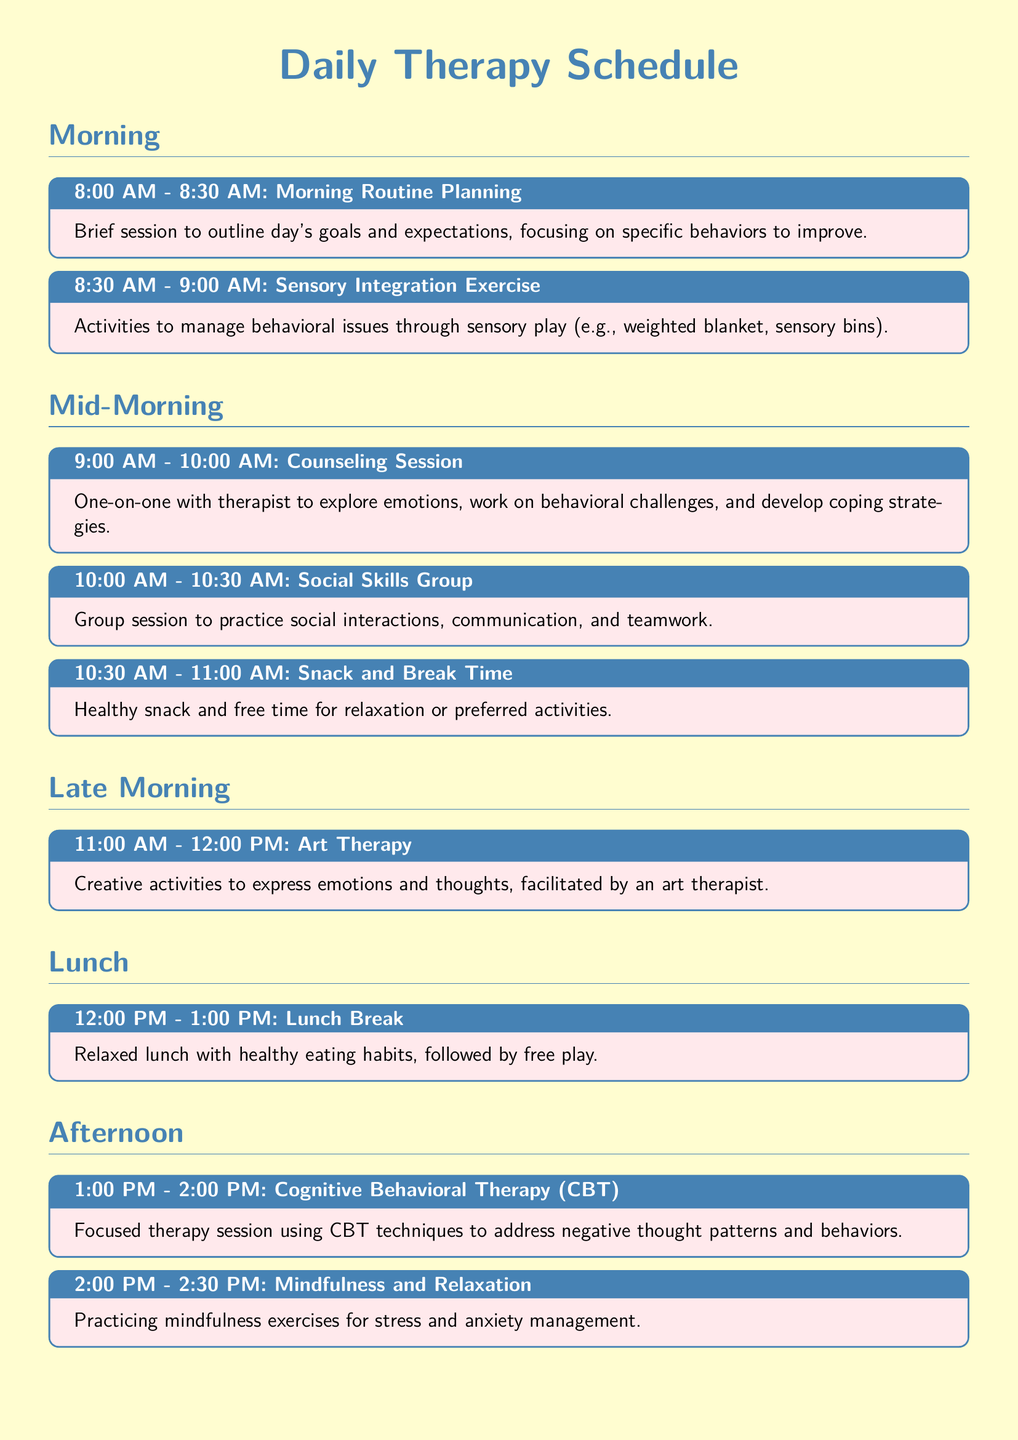What time does the Morning Routine Planning session start? The document states the Morning Routine Planning session starts at 8:00 AM.
Answer: 8:00 AM How long is the Counseling Session? The Counseling Session is outlined to take one hour, from 9:00 AM to 10:00 AM.
Answer: 1 hour What activity follows the Art Therapy session? The document indicates that the activity following Art Therapy, which ends at 12:00 PM, is Lunch Break.
Answer: Lunch Break What type of therapy is conducted in the afternoon from 1:00 PM? The document specifies that Cognitive Behavioral Therapy (CBT) is conducted starting at 1:00 PM.
Answer: Cognitive Behavioral Therapy (CBT) How many activities are scheduled between 1:00 PM and 3:00 PM? The document lists three different activities scheduled between 1:00 PM and 3:00 PM, including CBT, Mindfulness and Relaxation, and Recreational Therapy.
Answer: 3 activities What is the purpose of the Parent-Child Interaction Therapy? The document describes the Parent-Child Interaction Therapy as a guided session to improve the relationship and communication between child and parents.
Answer: Improve relationship and communication Which therapy focuses on sensory play? The activity focusing on sensory play is titled Sensory Integration Exercise.
Answer: Sensory Integration Exercise What time does the Daily Reflection activity take place? According to the document, the Daily Reflection activity takes place from 4:00 PM to 4:30 PM.
Answer: 4:00 PM to 4:30 PM 